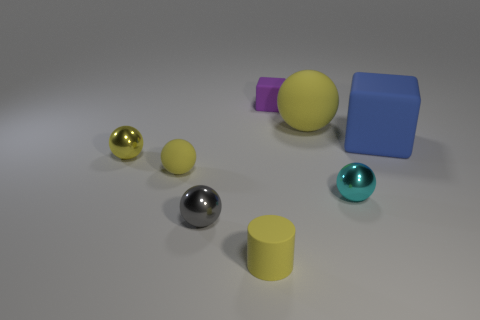Subtract all tiny yellow shiny spheres. How many spheres are left? 4 Add 1 cylinders. How many objects exist? 9 Subtract all blue blocks. How many blocks are left? 1 Subtract all cylinders. How many objects are left? 7 Subtract 2 blocks. How many blocks are left? 0 Subtract all tiny cyan metallic things. Subtract all tiny matte cylinders. How many objects are left? 6 Add 6 matte spheres. How many matte spheres are left? 8 Add 7 large purple objects. How many large purple objects exist? 7 Subtract 0 gray cylinders. How many objects are left? 8 Subtract all brown cylinders. Subtract all brown spheres. How many cylinders are left? 1 